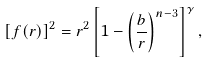<formula> <loc_0><loc_0><loc_500><loc_500>\left [ f ( r ) \right ] ^ { 2 } = r ^ { 2 } \left [ 1 - \left ( \frac { b } { r } \right ) ^ { n - 3 } \right ] ^ { \gamma } ,</formula> 